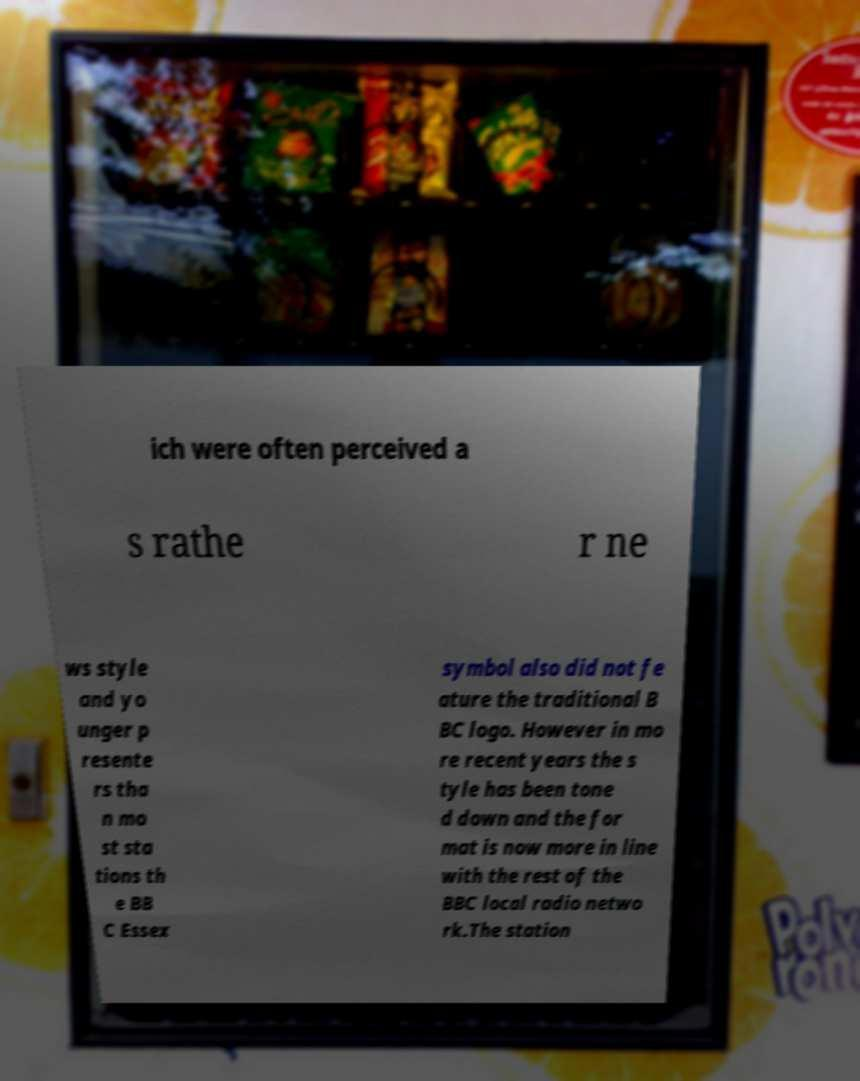Could you extract and type out the text from this image? ich were often perceived a s rathe r ne ws style and yo unger p resente rs tha n mo st sta tions th e BB C Essex symbol also did not fe ature the traditional B BC logo. However in mo re recent years the s tyle has been tone d down and the for mat is now more in line with the rest of the BBC local radio netwo rk.The station 